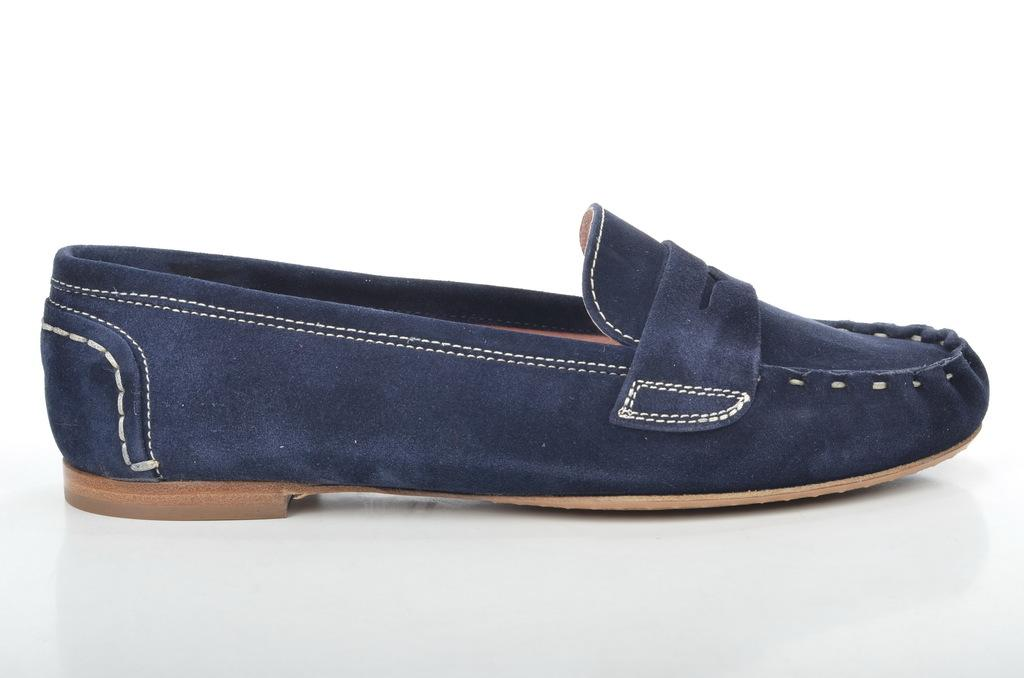What object is the main subject of the image? There is a shoe in the image. What is the color of the surface the shoe is placed on? The shoe is on a white surface. What type of copper lock can be seen securing the shoe in the image? There is no copper lock present in the image; it only features a shoe on a white surface. 